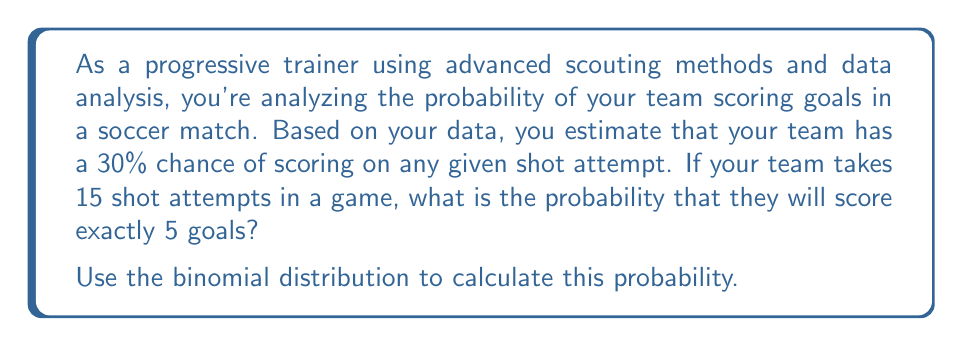Solve this math problem. To solve this problem, we'll use the binomial probability formula:

$$P(X = k) = \binom{n}{k} p^k (1-p)^{n-k}$$

Where:
$n$ = number of trials (shot attempts)
$k$ = number of successes (goals scored)
$p$ = probability of success on each trial (probability of scoring on each shot)

Given:
$n = 15$ (shot attempts)
$k = 5$ (goals scored)
$p = 0.30$ (30% chance of scoring on each shot)

Step 1: Calculate the binomial coefficient $\binom{n}{k}$
$$\binom{15}{5} = \frac{15!}{5!(15-5)!} = \frac{15!}{5!10!} = 3003$$

Step 2: Calculate $p^k$
$$0.30^5 = 0.00243$$

Step 3: Calculate $(1-p)^{n-k}$
$$(1-0.30)^{15-5} = 0.70^{10} = 0.02825$$

Step 4: Multiply all the terms
$$P(X = 5) = 3003 \times 0.00243 \times 0.02825 = 0.2061$$

Therefore, the probability of scoring exactly 5 goals in 15 shot attempts is approximately 0.2061 or 20.61%.
Answer: The probability of scoring exactly 5 goals in 15 shot attempts is 0.2061 or 20.61%. 